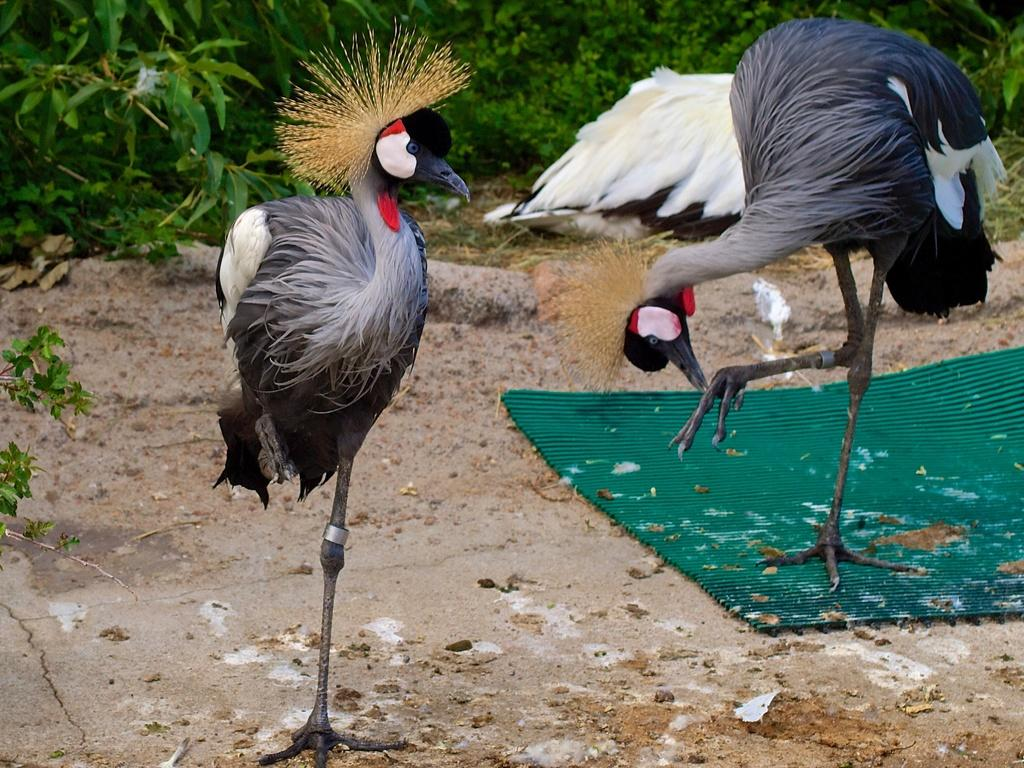What type of animals can be seen in the image? Birds can be seen in the image. What is covering the ground in the image? There is a sheet in the image. What can be seen in the background of the image? There are plants in the background of the image. What type of harbor can be seen in the image? There is no harbor present in the image; it features birds and a sheet on the ground. What reason can be given for the birds' presence in the image? The image does not provide a reason for the birds' presence; they are simply depicted in the scene. 